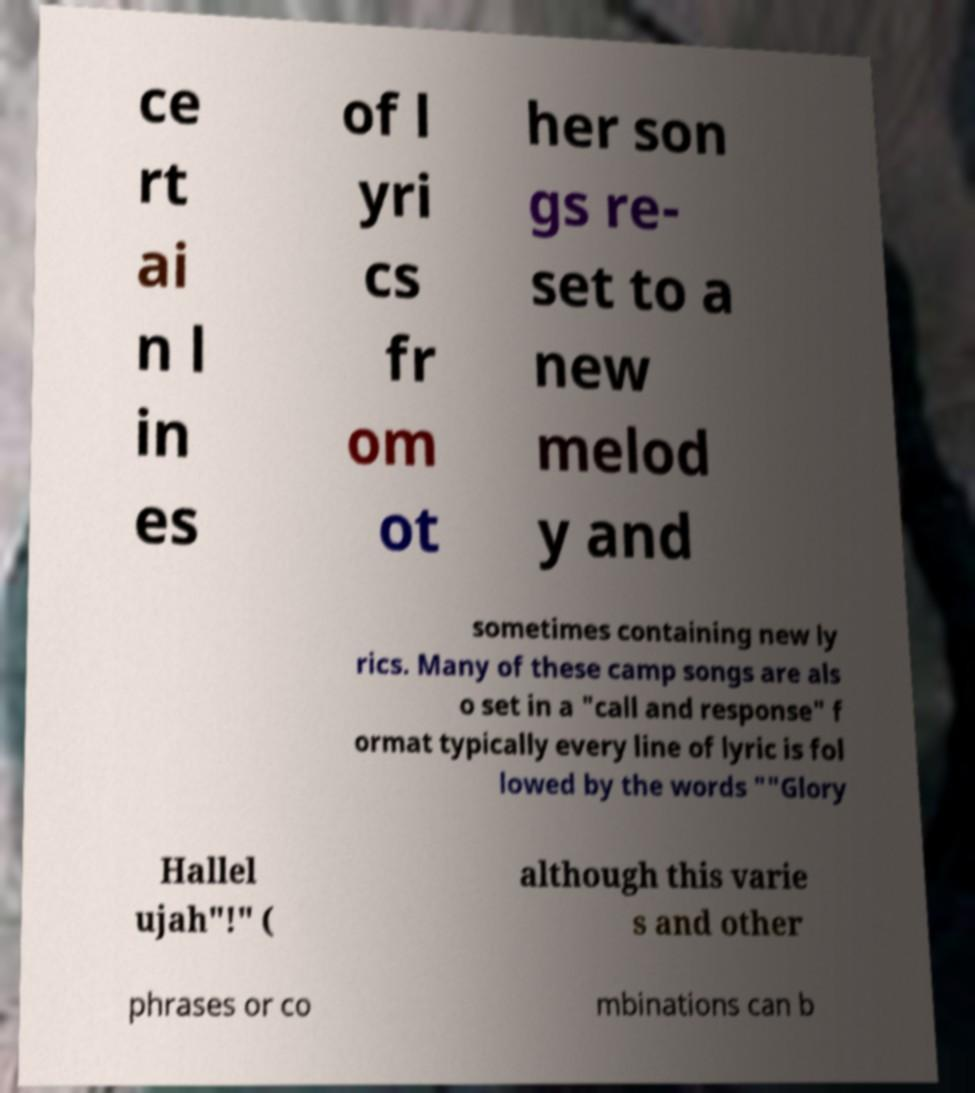I need the written content from this picture converted into text. Can you do that? ce rt ai n l in es of l yri cs fr om ot her son gs re- set to a new melod y and sometimes containing new ly rics. Many of these camp songs are als o set in a "call and response" f ormat typically every line of lyric is fol lowed by the words ""Glory Hallel ujah"!" ( although this varie s and other phrases or co mbinations can b 